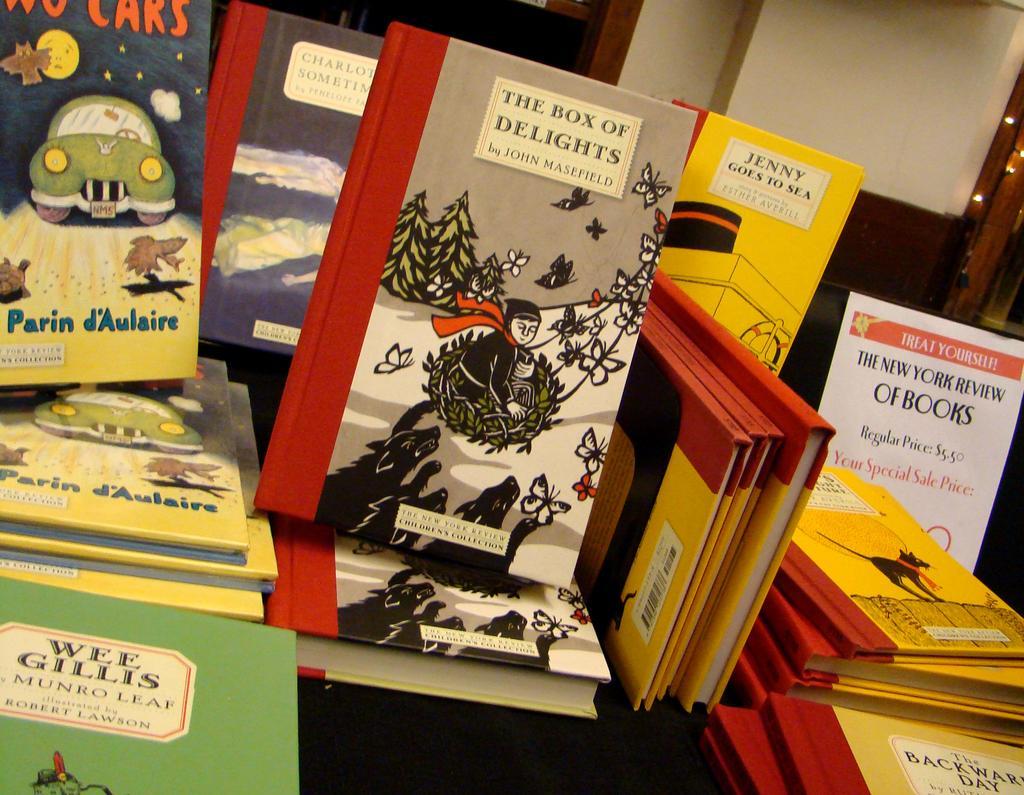Describe this image in one or two sentences. There are books in the foreground area of the image, it seems like windows, light, and a pillar in the background. 